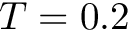<formula> <loc_0><loc_0><loc_500><loc_500>T = 0 . 2</formula> 